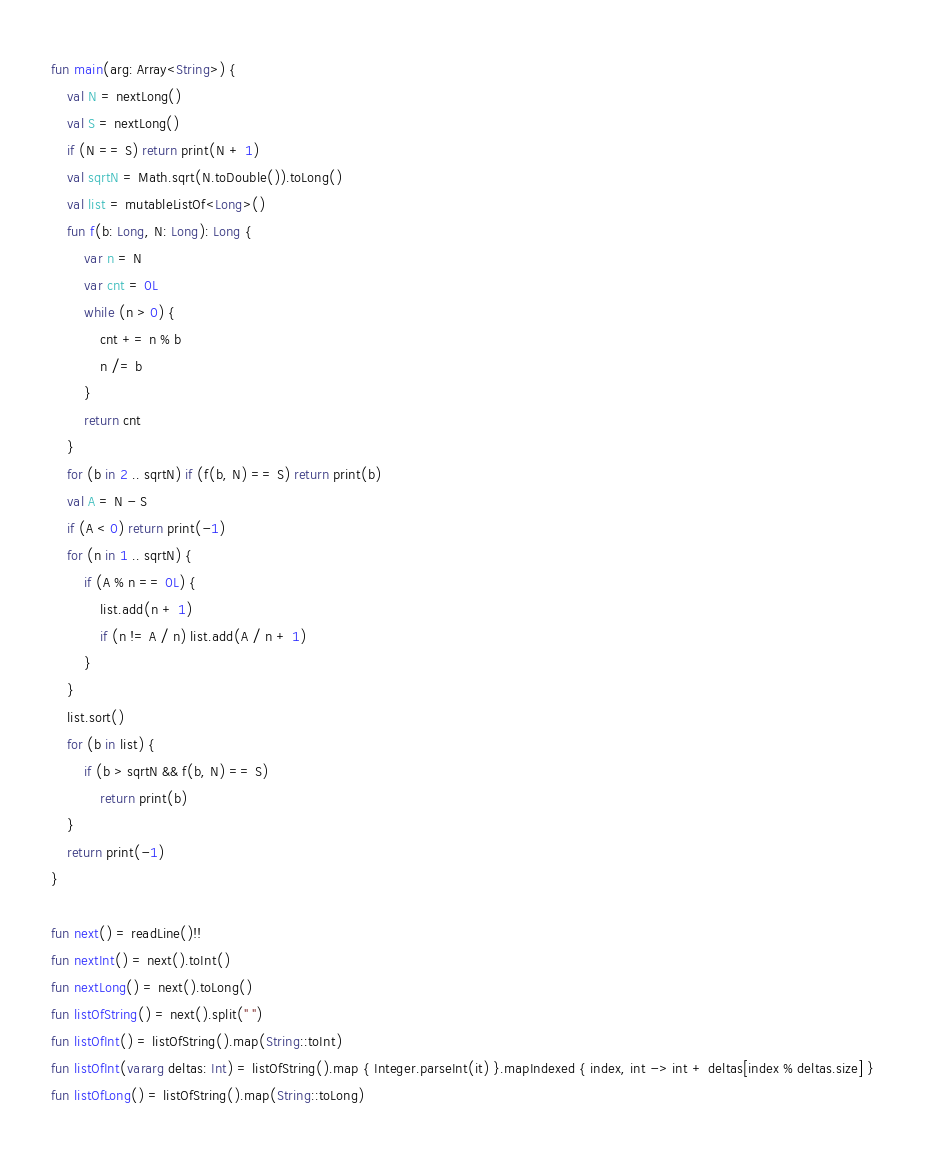Convert code to text. <code><loc_0><loc_0><loc_500><loc_500><_Kotlin_>fun main(arg: Array<String>) {
    val N = nextLong()
    val S = nextLong()
    if (N == S) return print(N + 1)
    val sqrtN = Math.sqrt(N.toDouble()).toLong()
    val list = mutableListOf<Long>()
    fun f(b: Long, N: Long): Long {
        var n = N
        var cnt = 0L
        while (n > 0) {
            cnt += n % b
            n /= b
        }
        return cnt
    }
    for (b in 2 .. sqrtN) if (f(b, N) == S) return print(b)
    val A = N - S
    if (A < 0) return print(-1)
    for (n in 1 .. sqrtN) {
        if (A % n == 0L) {
            list.add(n + 1)
            if (n != A / n) list.add(A / n + 1)
        }
    }
    list.sort()
    for (b in list) {
        if (b > sqrtN && f(b, N) == S)
            return print(b)
    }
    return print(-1)
}

fun next() = readLine()!!
fun nextInt() = next().toInt()
fun nextLong() = next().toLong()
fun listOfString() = next().split(" ")
fun listOfInt() = listOfString().map(String::toInt)
fun listOfInt(vararg deltas: Int) = listOfString().map { Integer.parseInt(it) }.mapIndexed { index, int -> int + deltas[index % deltas.size] }
fun listOfLong() = listOfString().map(String::toLong)

</code> 